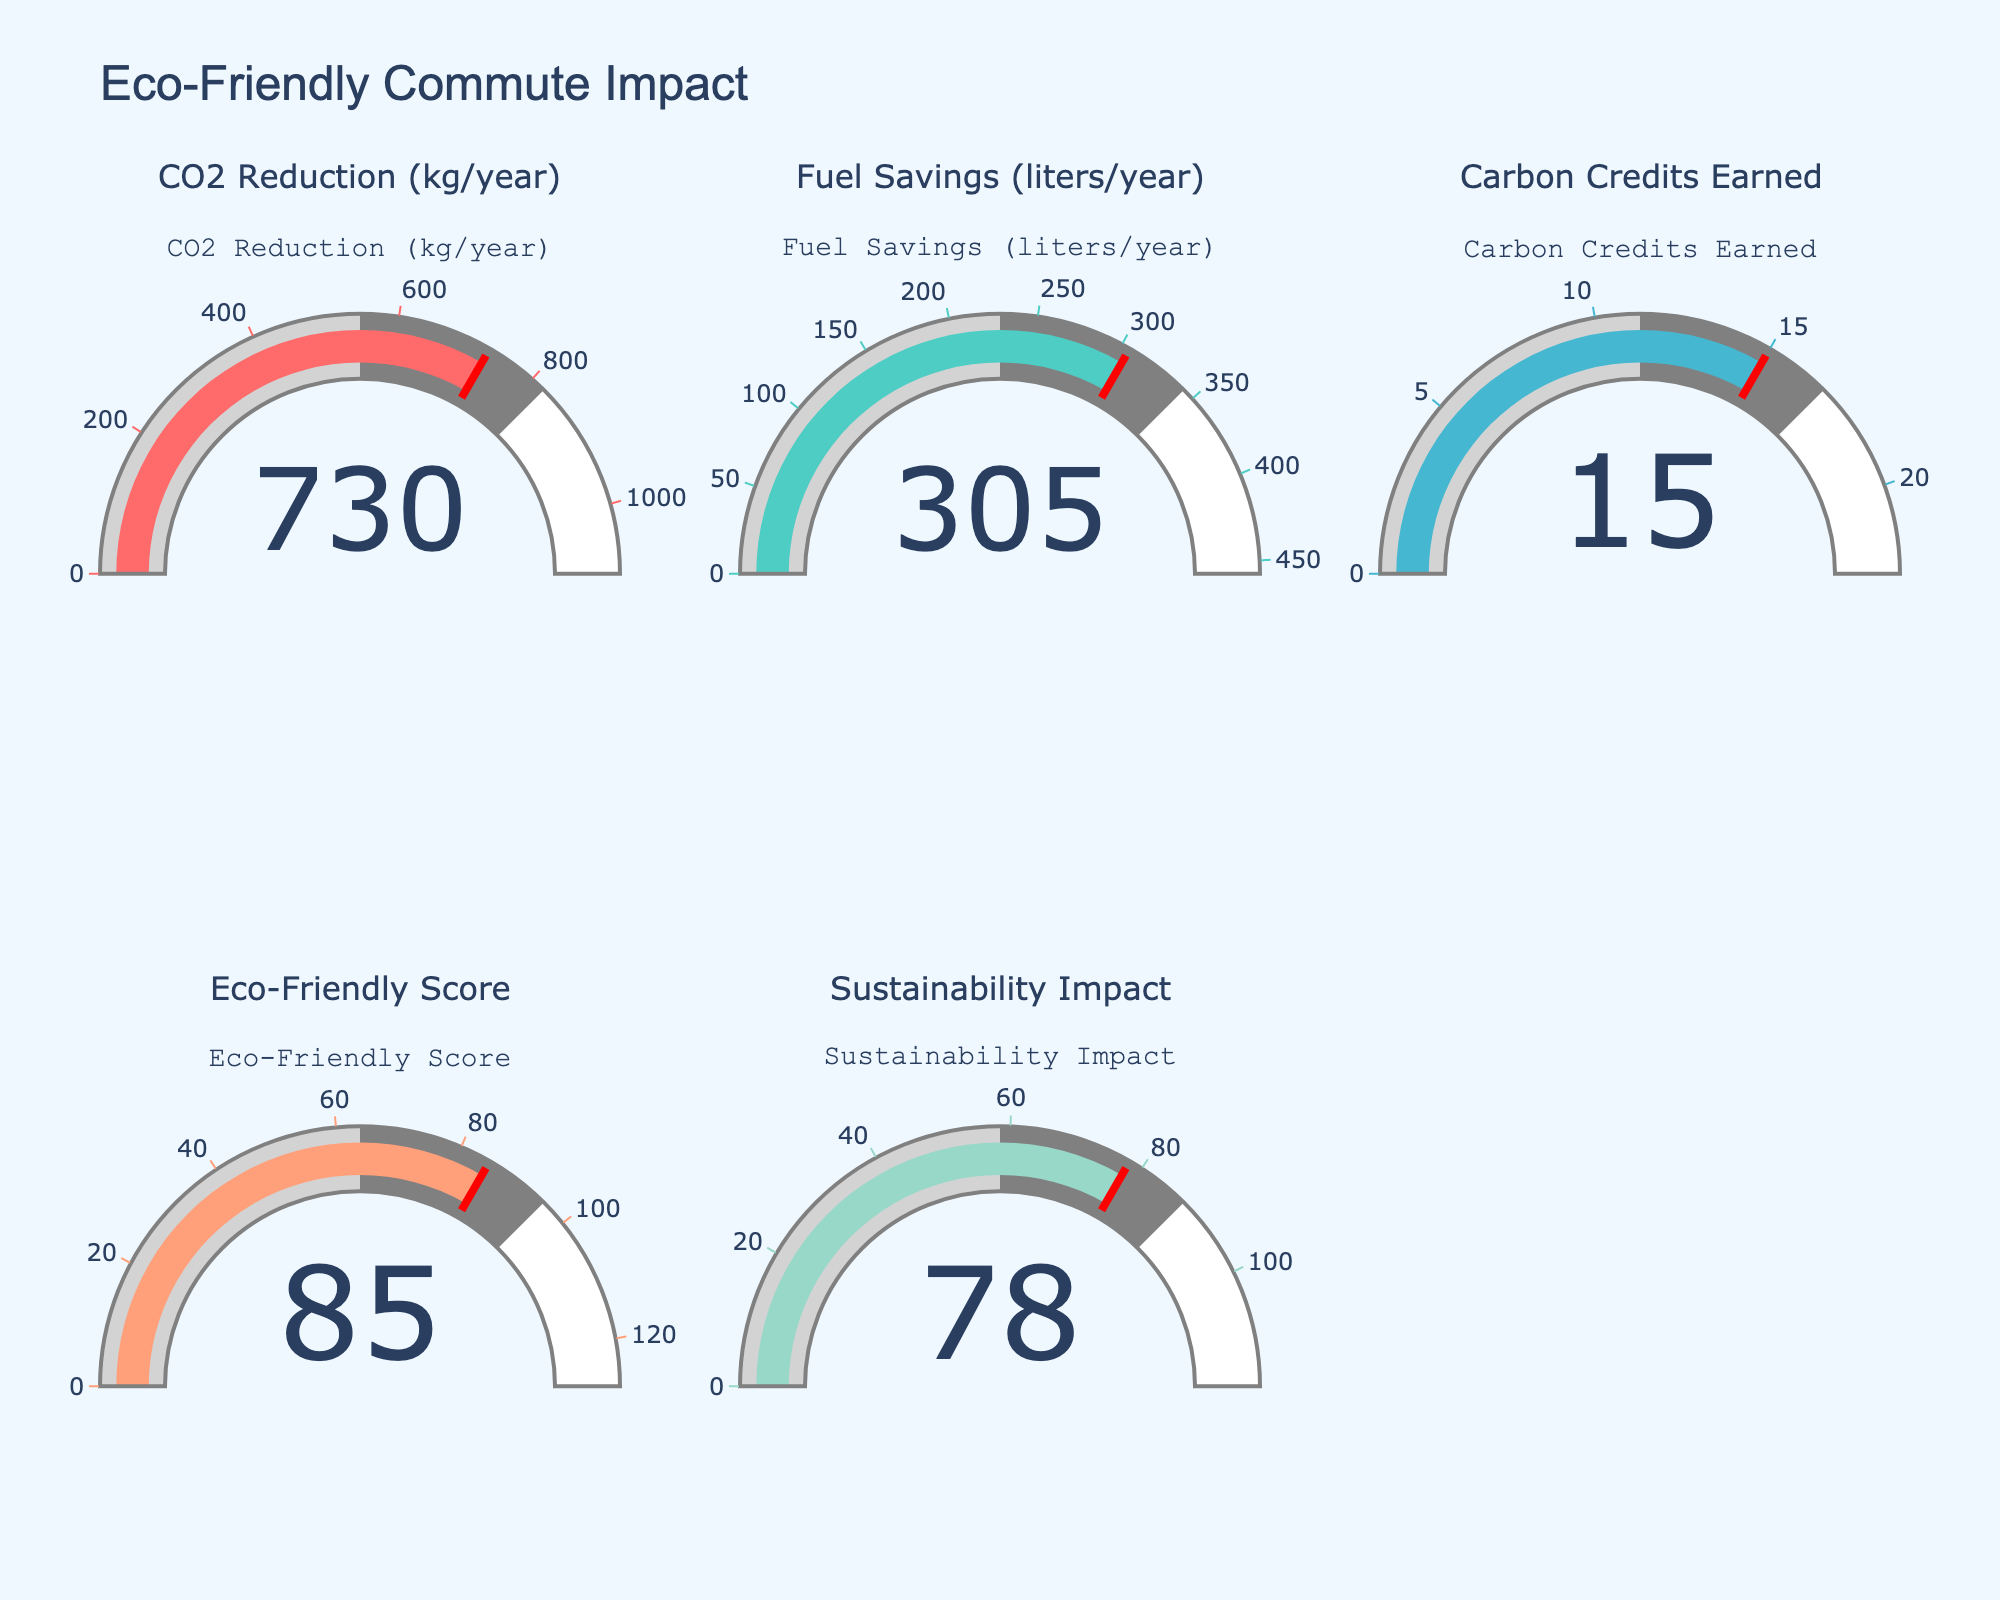Which metric has the highest value on the gauges? To determine which metric has the highest value, examine each gauge and their respective values. The metric "CO2 Reduction (kg/year)" shows the highest value at 730.
Answer: CO2 Reduction (kg/year) What is the value for the "Eco-Friendly Score"? Look at the gauge titled "Eco-Friendly Score" to find the value displayed in the center of the gauge indicator. The value shown is 85.
Answer: 85 Which metric appears in the bottom row, middle column? Identify the placement of each gauge by its position in the subplot grid. The "Eco-Friendly Score" metric is located in the bottom row, middle column.
Answer: Eco-Friendly Score What is the combined value of "Fuel Savings (liters/year)" and "Carbon Credits Earned"? Add the values of "Fuel Savings (liters/year)" which is 305, and "Carbon Credits Earned" which is 15. So, 305 + 15 = 320.
Answer: 320 Which metric shows a value of 78? Find the gauge displaying the value of 78 and check its title. The gauge titled "Sustainability Impact" shows 78.
Answer: Sustainability Impact Are there any metrics with a value less than 50? Review the values in all gauges to see if any are less than 50. The lowest value is 15 from "Carbon Credits Earned," which is less than 50.
Answer: Yes, Carbon Credits Earned Which metric occupies the first gauge from the left in the top row? Locate the first gauge from the left in the top row. The title reads "CO2 Reduction (kg/year)", indicating this is the metric shown.
Answer: CO2 Reduction (kg/year) What's the difference between "CO2 Reduction (kg/year)" and "Sustainability Impact"? Calculate the difference by subtracting the value of "Sustainability Impact" (78) from "CO2 Reduction (kg/year)" (730). So, 730 - 78 = 652.
Answer: 652 